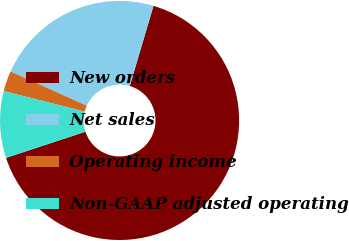<chart> <loc_0><loc_0><loc_500><loc_500><pie_chart><fcel>New orders<fcel>Net sales<fcel>Operating income<fcel>Non-GAAP adjusted operating<nl><fcel>65.36%<fcel>22.85%<fcel>2.77%<fcel>9.02%<nl></chart> 